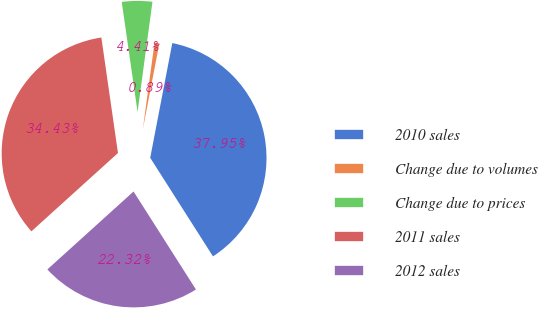Convert chart. <chart><loc_0><loc_0><loc_500><loc_500><pie_chart><fcel>2010 sales<fcel>Change due to volumes<fcel>Change due to prices<fcel>2011 sales<fcel>2012 sales<nl><fcel>37.95%<fcel>0.89%<fcel>4.41%<fcel>34.43%<fcel>22.32%<nl></chart> 